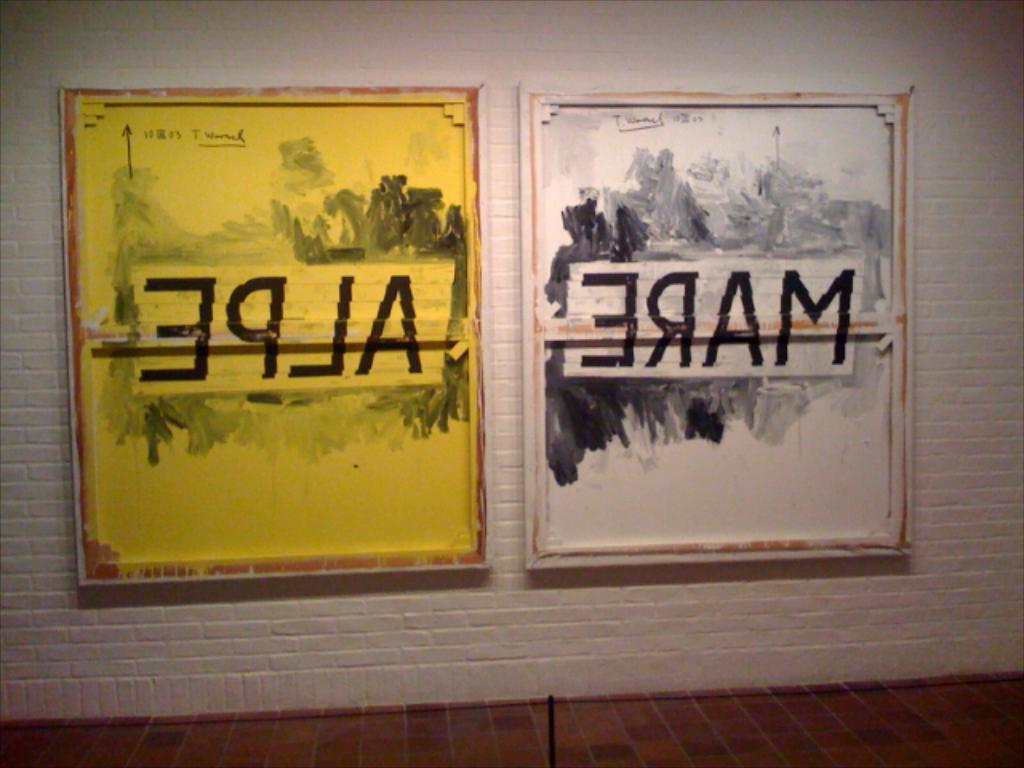<image>
Present a compact description of the photo's key features. A painting in white and yellow with Mare Alpe in backward letters. 